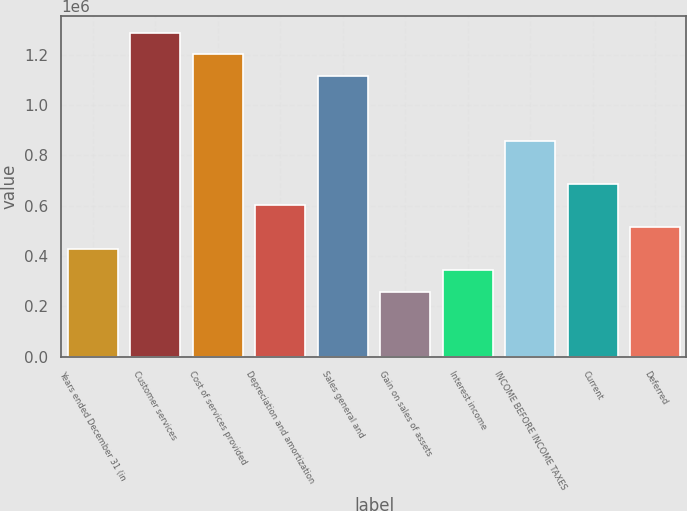<chart> <loc_0><loc_0><loc_500><loc_500><bar_chart><fcel>Years ended December 31 (in<fcel>Customer services<fcel>Cost of services provided<fcel>Depreciation and amortization<fcel>Sales general and<fcel>Gain on sales of assets<fcel>Interest income<fcel>INCOME BEFORE INCOME TAXES<fcel>Current<fcel>Deferred<nl><fcel>429439<fcel>1.28832e+06<fcel>1.20243e+06<fcel>601215<fcel>1.11654e+06<fcel>257664<fcel>343551<fcel>858878<fcel>687102<fcel>515327<nl></chart> 